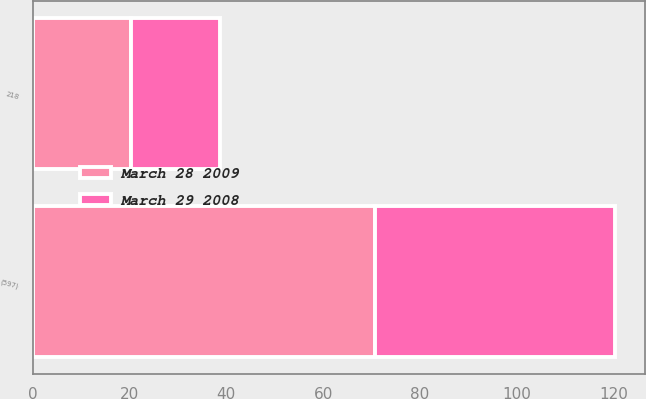Convert chart. <chart><loc_0><loc_0><loc_500><loc_500><stacked_bar_chart><ecel><fcel>(597)<fcel>218<nl><fcel>March 29 2008<fcel>49.7<fcel>18.5<nl><fcel>March 28 2009<fcel>70.7<fcel>20.2<nl></chart> 